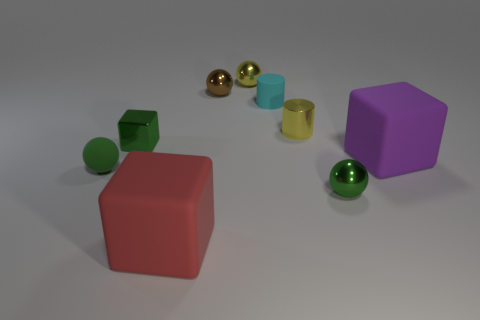What is the shape of the tiny shiny thing that is the same color as the tiny metallic cube?
Keep it short and to the point. Sphere. How big is the brown metal thing that is to the left of the matte object that is right of the yellow metallic cylinder?
Offer a very short reply. Small. Are there more big cyan spheres than tiny green shiny balls?
Offer a terse response. No. Are there more tiny brown balls that are left of the tiny green shiny block than large rubber things right of the small brown shiny thing?
Ensure brevity in your answer.  No. What size is the object that is both to the left of the large red rubber cube and behind the purple object?
Your answer should be compact. Small. What number of red things are the same size as the red rubber block?
Your answer should be compact. 0. What is the material of the ball that is the same color as the shiny cylinder?
Your answer should be very brief. Metal. There is a tiny green object to the left of the small green metallic cube; is it the same shape as the tiny brown thing?
Give a very brief answer. Yes. Are there fewer large red matte objects that are to the right of the rubber cylinder than small matte cylinders?
Offer a very short reply. Yes. Is there a small metal thing of the same color as the small metal cylinder?
Make the answer very short. Yes. 